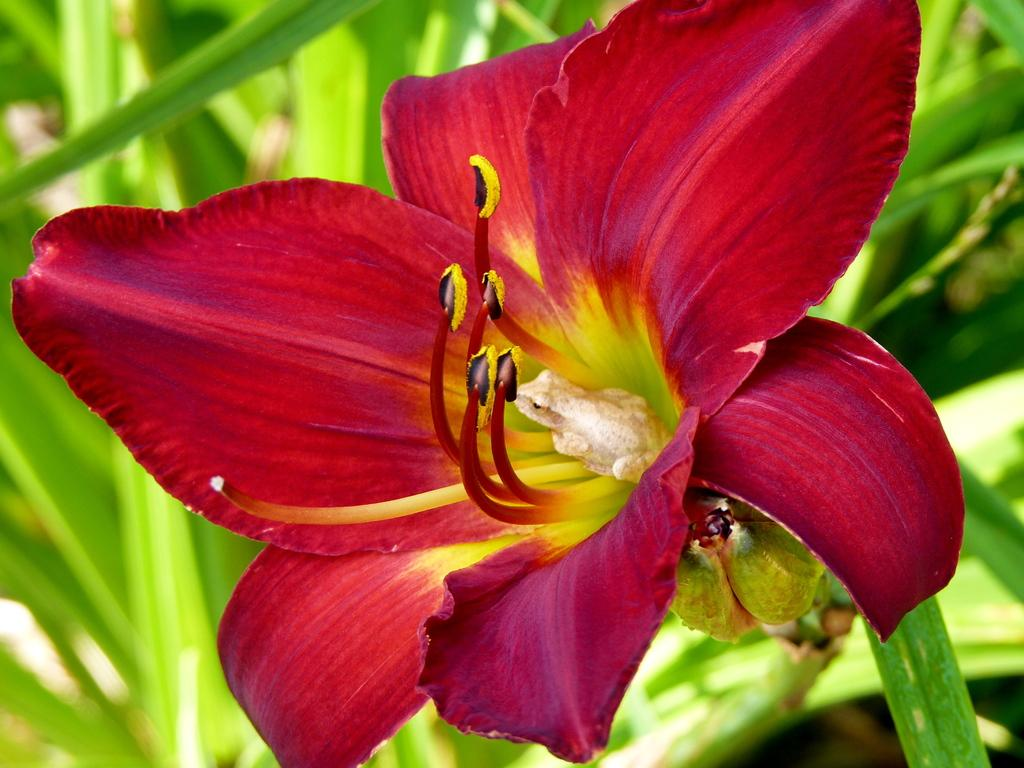What is the main subject in the front of the image? There is a flower in the front of the image. What can be seen in the background of the image? There are leaves in the background of the image. What part of the flower is visible? The petals of the flower are visible. How does the flower support the weight of the hot object in the image? There is no hot object present in the image, and the flower is not supporting any weight. 